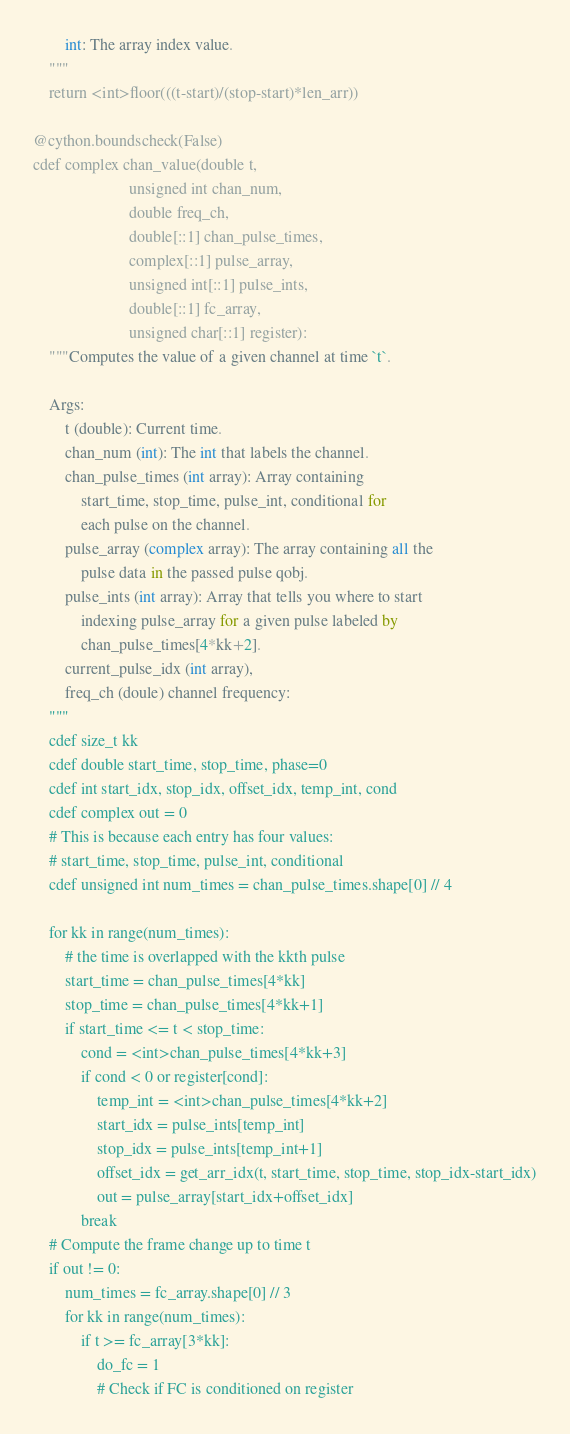<code> <loc_0><loc_0><loc_500><loc_500><_Cython_>        int: The array index value.
    """
    return <int>floor(((t-start)/(stop-start)*len_arr))

@cython.boundscheck(False)
cdef complex chan_value(double t,
                        unsigned int chan_num,
                        double freq_ch,
                        double[::1] chan_pulse_times,
                        complex[::1] pulse_array,
                        unsigned int[::1] pulse_ints,
                        double[::1] fc_array,
                        unsigned char[::1] register):
    """Computes the value of a given channel at time `t`.

    Args:
        t (double): Current time.
        chan_num (int): The int that labels the channel.
        chan_pulse_times (int array): Array containing
            start_time, stop_time, pulse_int, conditional for
            each pulse on the channel.
        pulse_array (complex array): The array containing all the
            pulse data in the passed pulse qobj.
        pulse_ints (int array): Array that tells you where to start
            indexing pulse_array for a given pulse labeled by
            chan_pulse_times[4*kk+2].
        current_pulse_idx (int array),
        freq_ch (doule) channel frequency:
    """
    cdef size_t kk
    cdef double start_time, stop_time, phase=0
    cdef int start_idx, stop_idx, offset_idx, temp_int, cond
    cdef complex out = 0
    # This is because each entry has four values:
    # start_time, stop_time, pulse_int, conditional
    cdef unsigned int num_times = chan_pulse_times.shape[0] // 4

    for kk in range(num_times):
        # the time is overlapped with the kkth pulse
        start_time = chan_pulse_times[4*kk]
        stop_time = chan_pulse_times[4*kk+1]
        if start_time <= t < stop_time:
            cond = <int>chan_pulse_times[4*kk+3]
            if cond < 0 or register[cond]:
                temp_int = <int>chan_pulse_times[4*kk+2]
                start_idx = pulse_ints[temp_int]
                stop_idx = pulse_ints[temp_int+1]
                offset_idx = get_arr_idx(t, start_time, stop_time, stop_idx-start_idx)
                out = pulse_array[start_idx+offset_idx]
            break
    # Compute the frame change up to time t
    if out != 0:
        num_times = fc_array.shape[0] // 3
        for kk in range(num_times):
            if t >= fc_array[3*kk]:
                do_fc = 1
                # Check if FC is conditioned on register</code> 